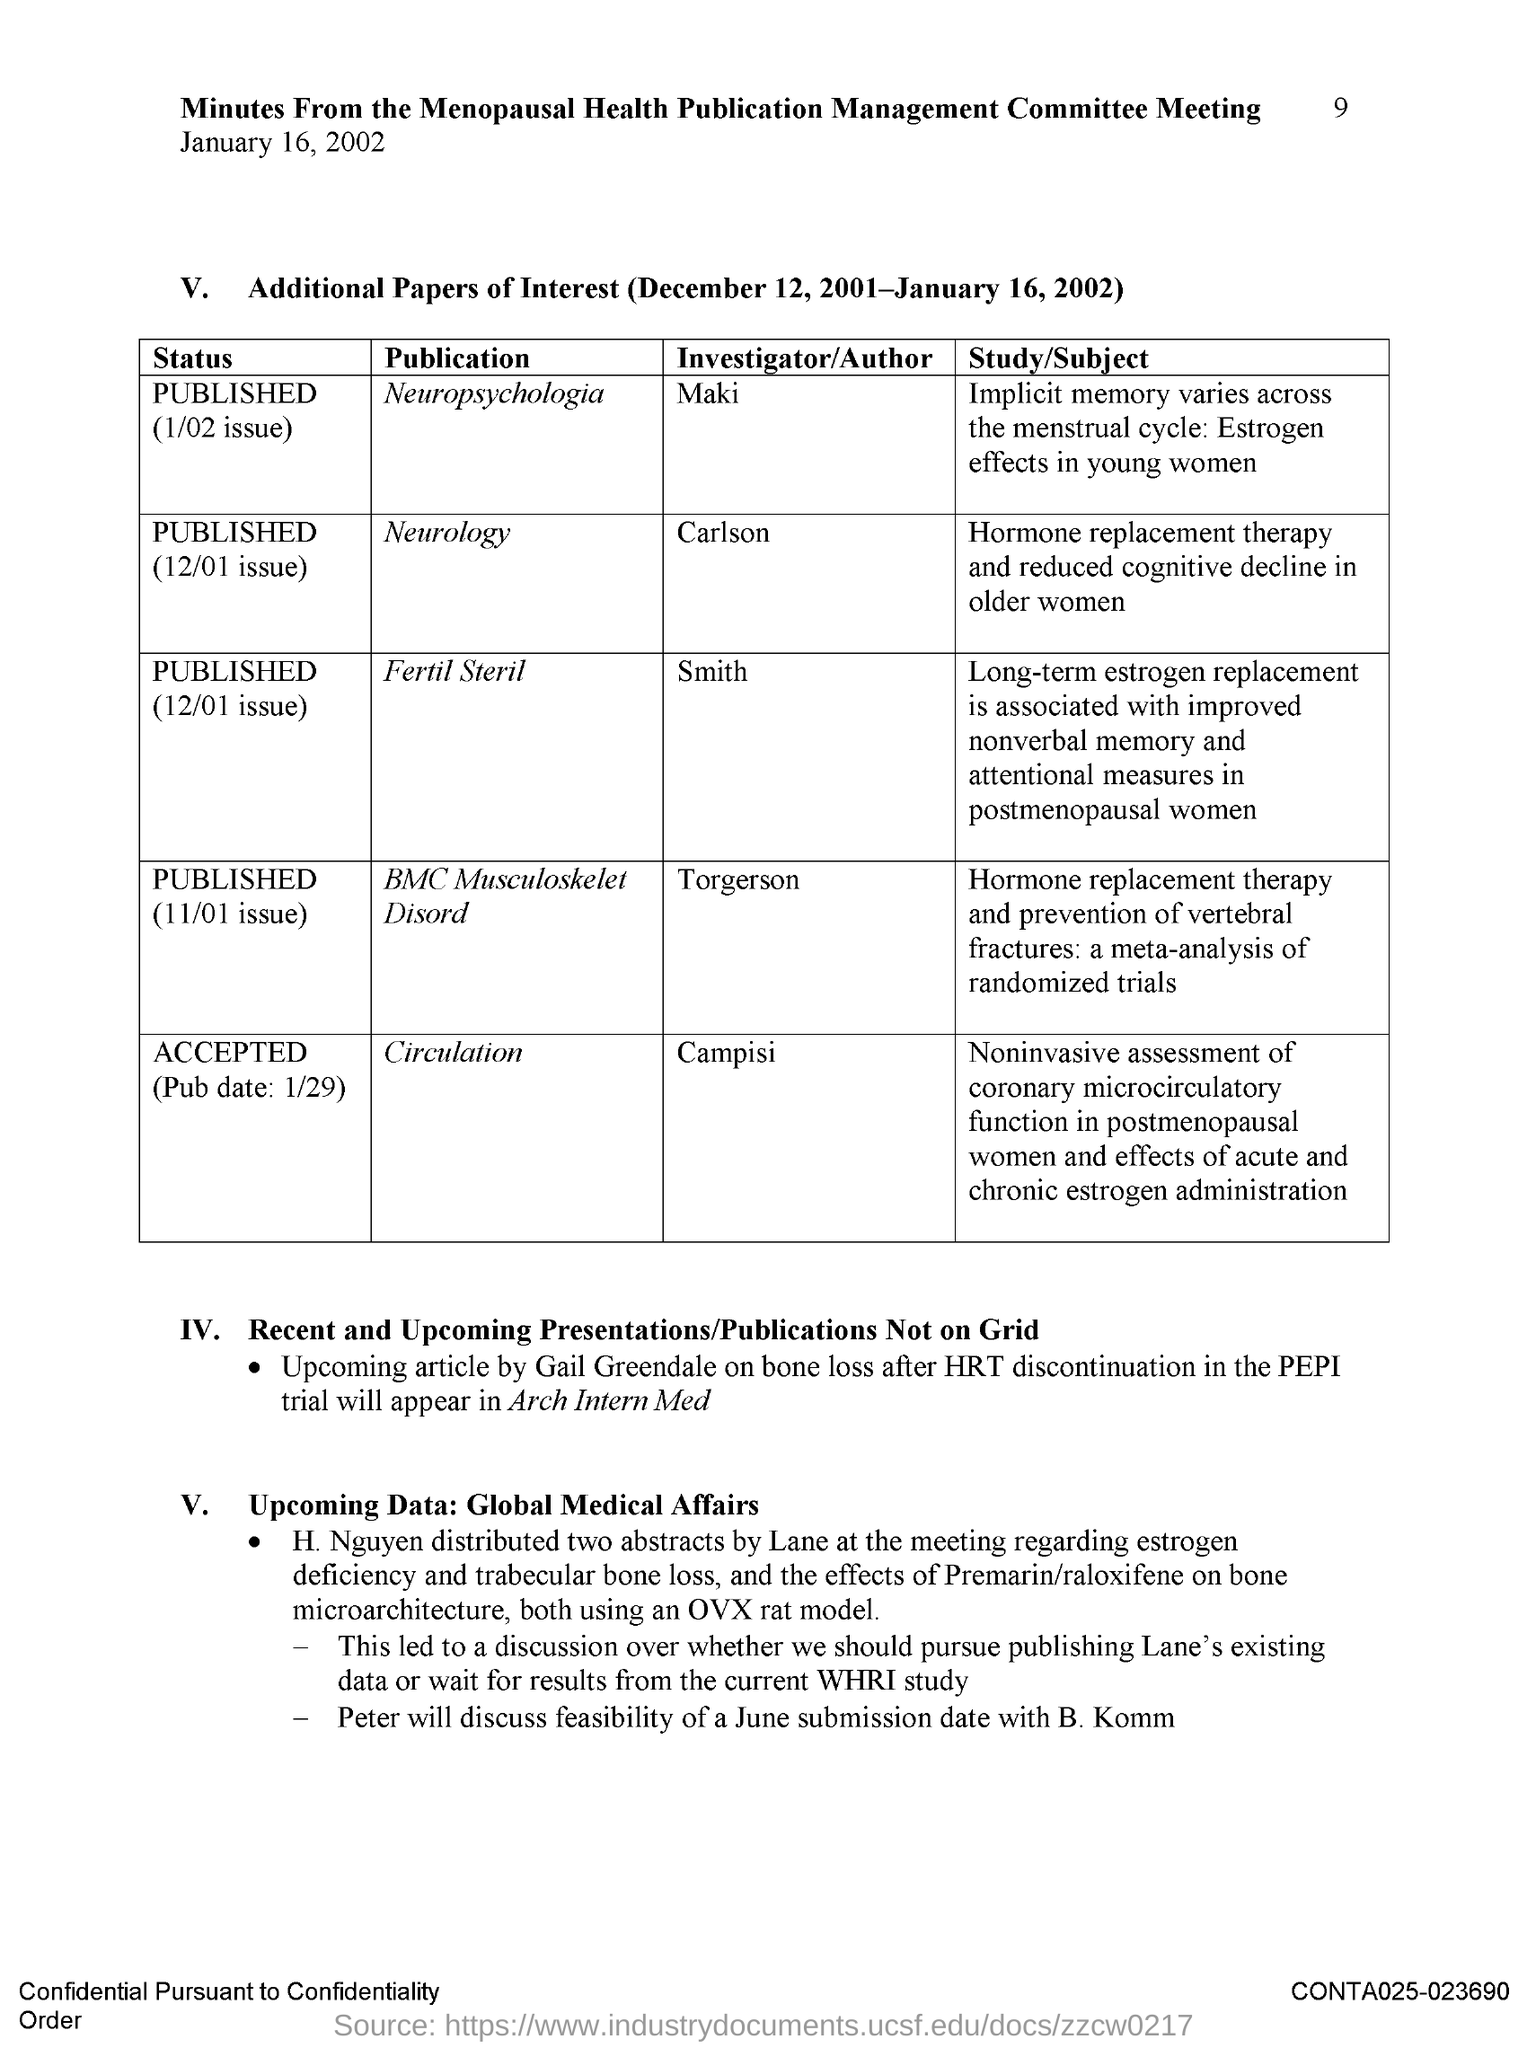What is the Page Number?
Offer a terse response. 9. Who is the author of the publication "Neurology"?
Make the answer very short. Carlson. Who is the author of the publication "Circulation"?
Provide a succinct answer. Campisi. Who is the author of the publication "Fertil Steril"?
Give a very brief answer. Smith. Who is the author of the publication "Neuropsychologia"?
Offer a terse response. Maki. 